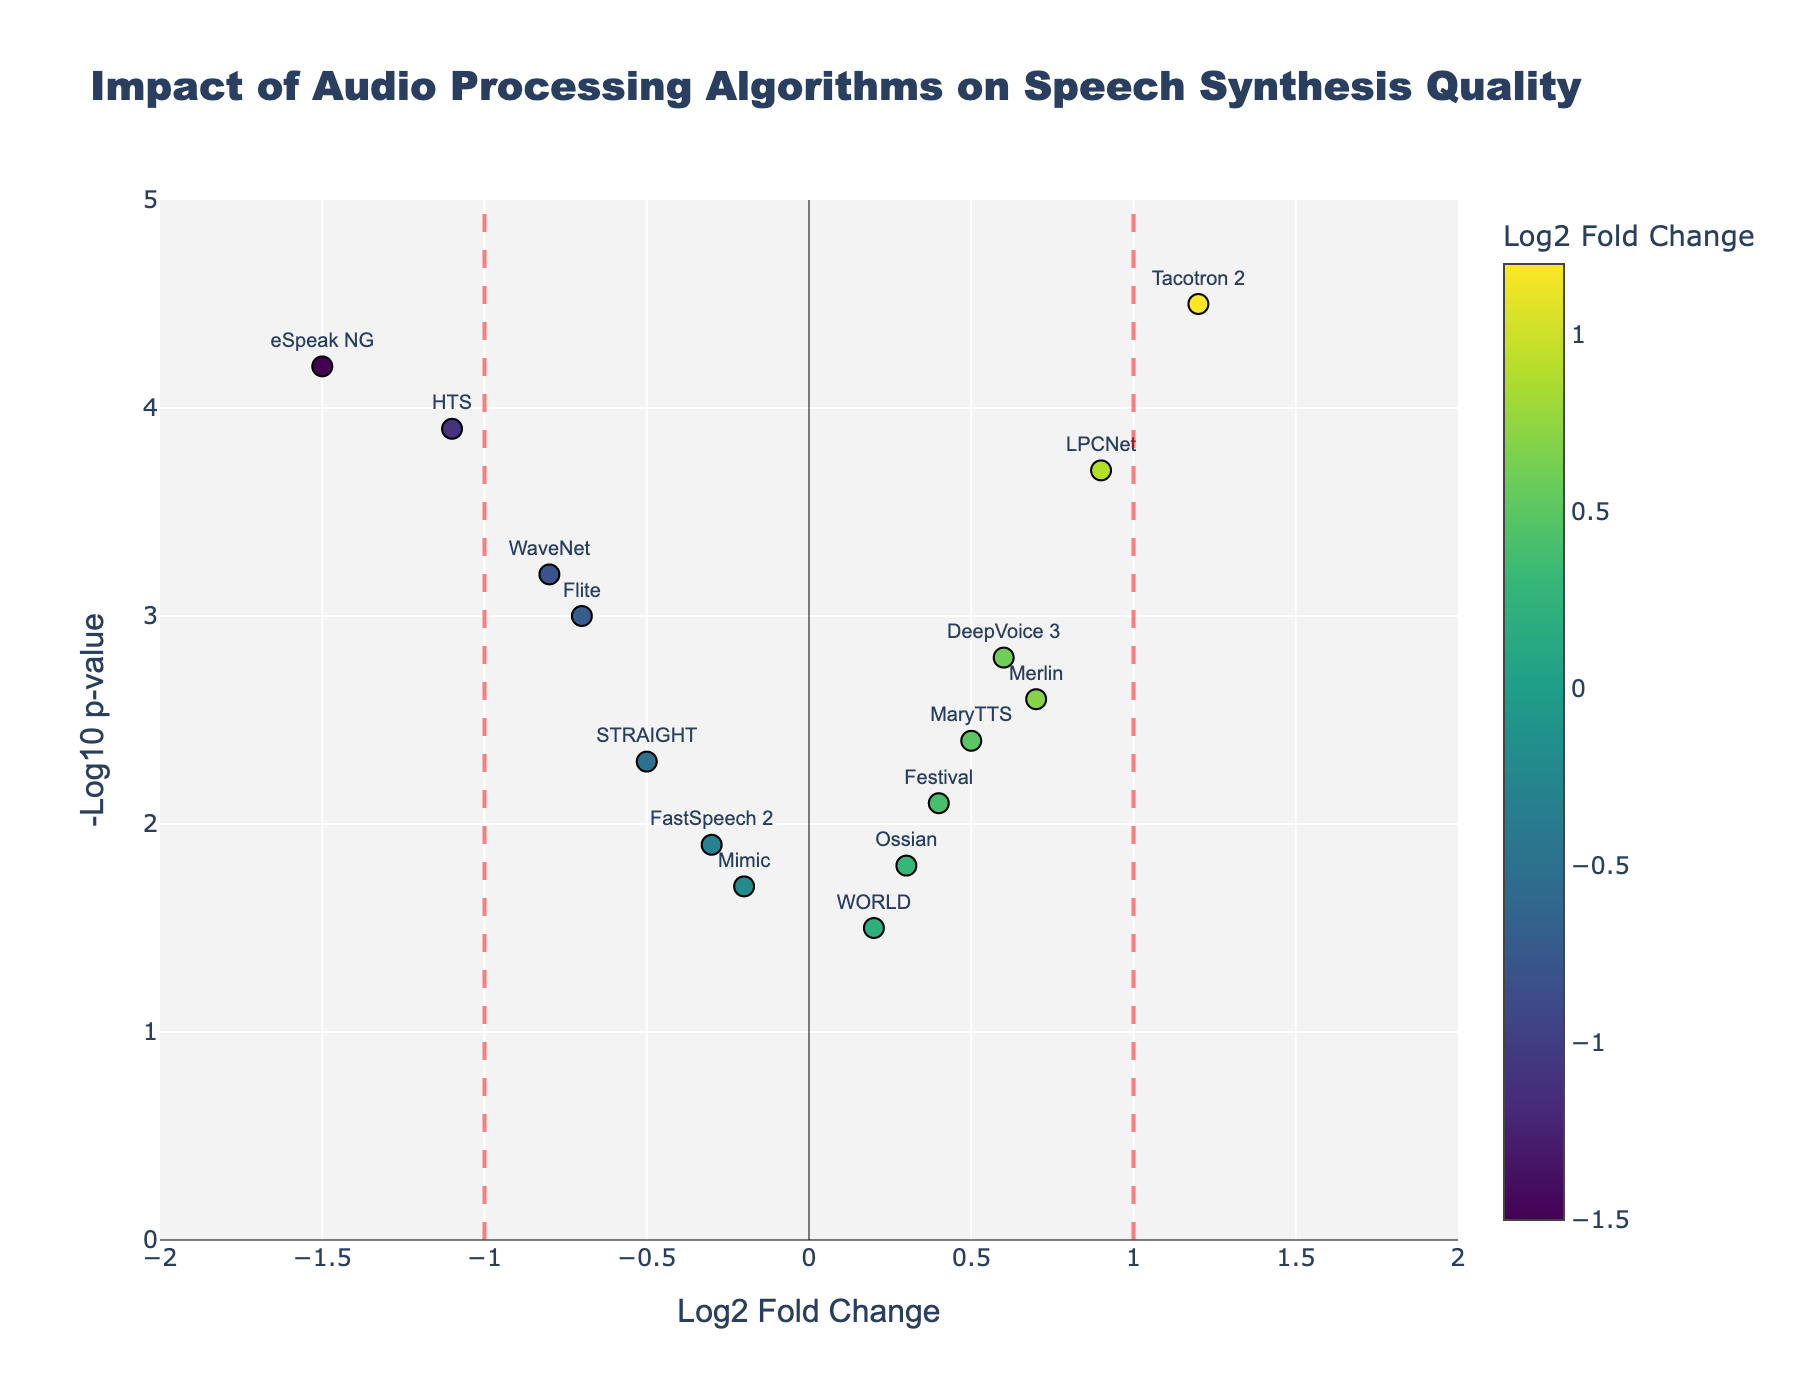What is the title of the figure? The title of the figure is usually displayed prominently at the top and provides a summary of what the plot represents. In this case, it is stated in the code.
Answer: Impact of Audio Processing Algorithms on Speech Synthesis Quality Which algorithm has the highest -Log10 p-value? Look for the highest point on the y-axis since -Log10 p-value is represented on the y-axis.
Answer: Tacotron 2 How many algorithms have a Log2 Fold Change greater than 0.5? Find data points with x-values (Log2 Fold Change) greater than 0.5 and count them.
Answer: 4 Which algorithm shows the most negative impact on speech synthesis quality? This is determined by the most negative Log2 Fold Change, represented by the leftmost point on the x-axis.
Answer: eSpeak NG Identify the range of the x-axis and y-axis. Check the axis labels and their corresponding values from the data and the layout settings in the code.
Answer: x-axis: -2 to 2, y-axis: 0 to 5 Which algorithms fall outside the vertical threshold lines at -1 and 1? Identify points where Log2 Fold Change (x-values) is outside the range of -1 and 1.
Answer: eSpeak NG, HTS, WaveNet, Tacotron 2 Calculate the average Log2 Fold Change of all the algorithms. Sum all Log2 Fold Change values and divide by the number of algorithms.
Answer: (-0.8 + 1.2 + 0.6 - 0.3 + 0.9 + 0.2 - 0.5 - 1.1 + 0.7 - 1.5 + 0.4 - 0.7 + 0.5 - 0.2 + 0.3) / 15 ≈ -0.067 Which algorithm has the closest to zero Log2 Fold Change? Find the data point with a Log2 Fold Change value nearest to zero.
Answer: Ossian Compare the -Log10 p-values of WaveNet and eSpeak NG. Which one is higher? Locate the y-values for both WaveNet and eSpeak NG and compare them.
Answer: eSpeak NG What color represents the highest Log2 Fold Change? Looking at the color scale bar and the corresponding text labels, find the color for the highest value.
Answer: Bright yellow 